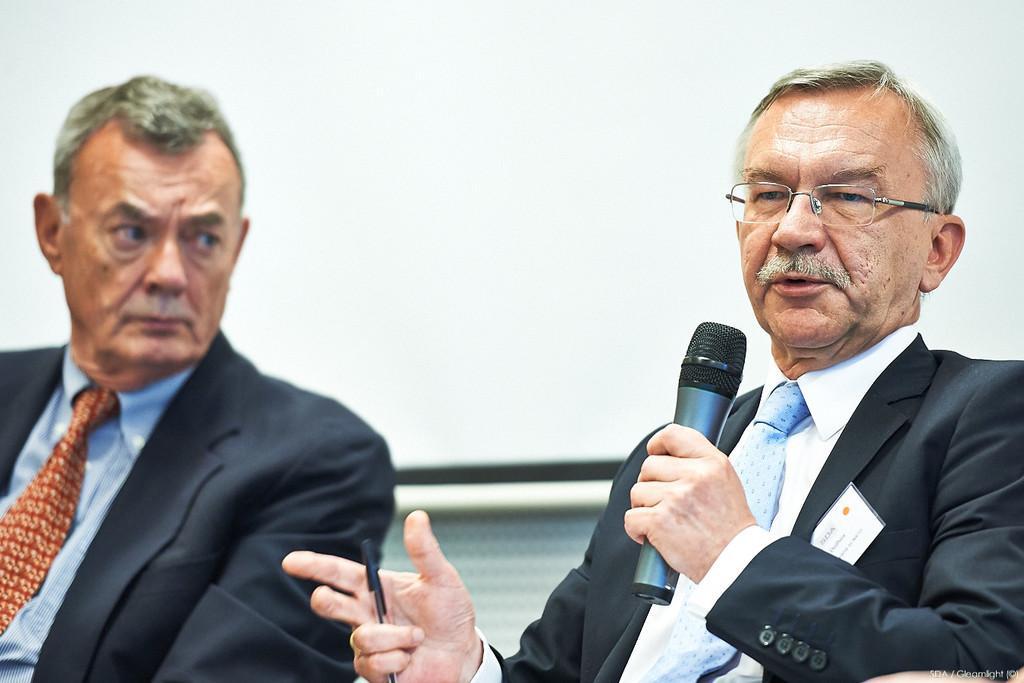Could you give a brief overview of what you see in this image? There are two people sitting. One person is holding mike and speaking. This is a badge attached to the suit. He holding a pen in his hand and the background is white in color. 